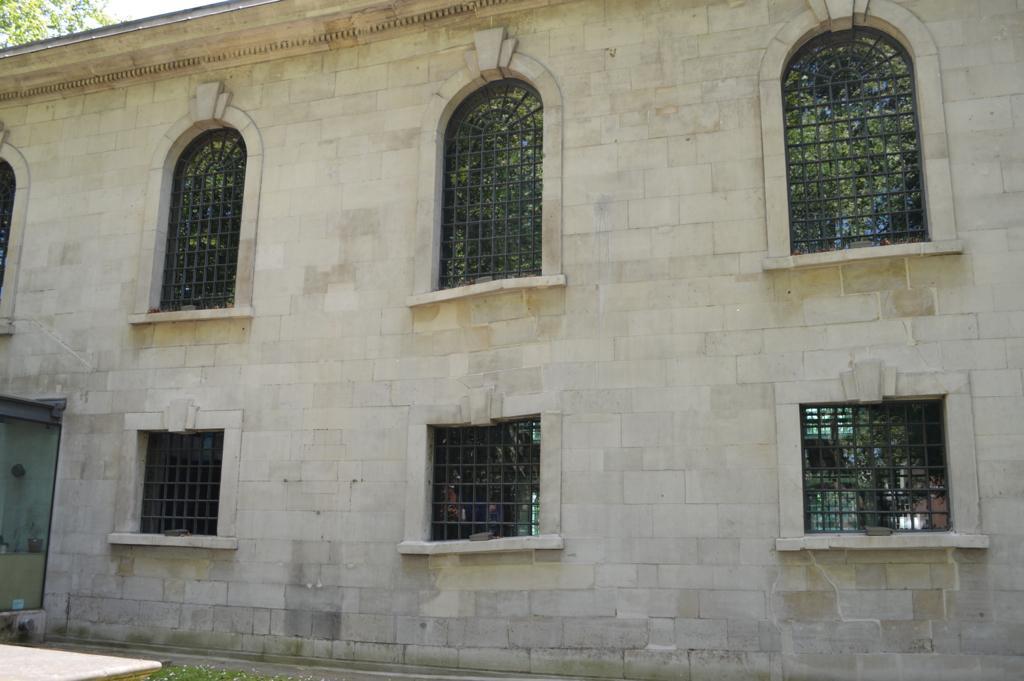Please provide a concise description of this image. In this picture we can see a wall of an old building with square shaped windows at the bottom and U shaped windows at the top and the windows have iron grills. 